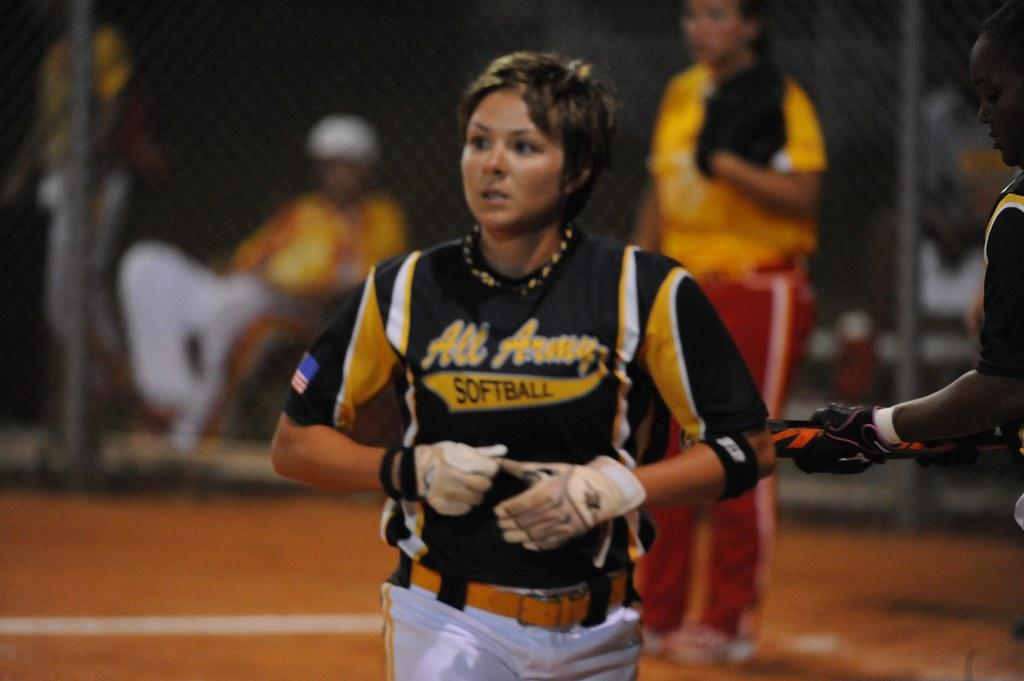<image>
Write a terse but informative summary of the picture. A woman athlete in her black and gold uniform with the word "softball" written on it. 